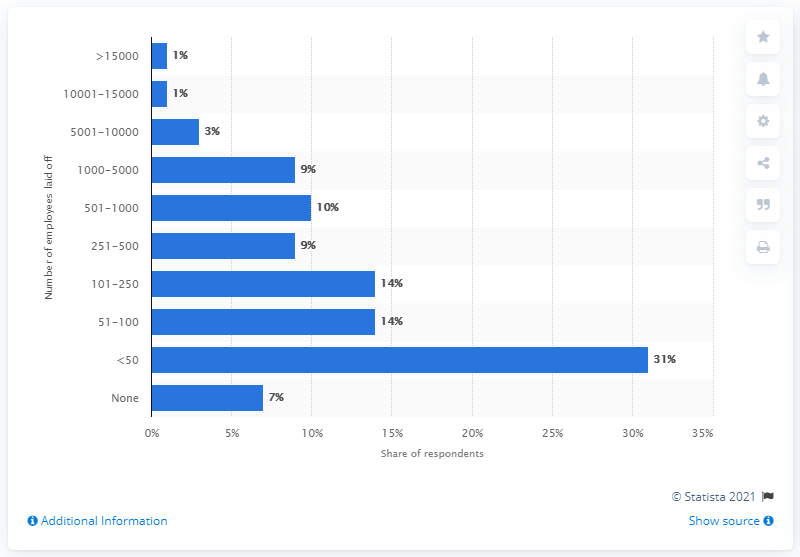Draw attention to some important aspects in this diagram. According to the response provided, 31% of the respondents stated that less than 50 employees had been laid off at their company. 